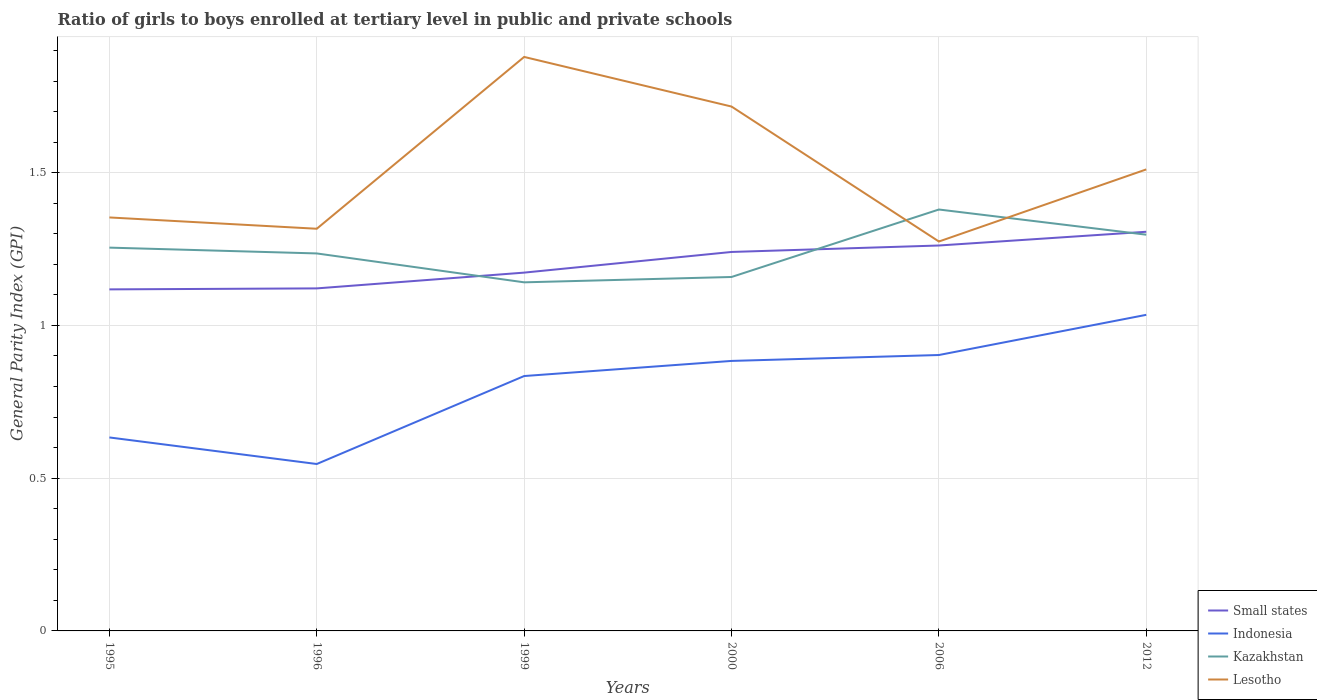How many different coloured lines are there?
Your response must be concise. 4. Does the line corresponding to Indonesia intersect with the line corresponding to Small states?
Keep it short and to the point. No. Across all years, what is the maximum general parity index in Indonesia?
Your answer should be compact. 0.55. In which year was the general parity index in Small states maximum?
Provide a short and direct response. 1995. What is the total general parity index in Lesotho in the graph?
Your answer should be compact. 0.37. What is the difference between the highest and the second highest general parity index in Indonesia?
Ensure brevity in your answer.  0.49. What is the difference between the highest and the lowest general parity index in Small states?
Ensure brevity in your answer.  3. Are the values on the major ticks of Y-axis written in scientific E-notation?
Make the answer very short. No. Does the graph contain grids?
Your response must be concise. Yes. Where does the legend appear in the graph?
Your answer should be very brief. Bottom right. How are the legend labels stacked?
Offer a terse response. Vertical. What is the title of the graph?
Give a very brief answer. Ratio of girls to boys enrolled at tertiary level in public and private schools. What is the label or title of the Y-axis?
Give a very brief answer. General Parity Index (GPI). What is the General Parity Index (GPI) of Small states in 1995?
Your answer should be compact. 1.12. What is the General Parity Index (GPI) in Indonesia in 1995?
Keep it short and to the point. 0.63. What is the General Parity Index (GPI) of Kazakhstan in 1995?
Make the answer very short. 1.25. What is the General Parity Index (GPI) of Lesotho in 1995?
Your answer should be very brief. 1.35. What is the General Parity Index (GPI) of Small states in 1996?
Your answer should be very brief. 1.12. What is the General Parity Index (GPI) in Indonesia in 1996?
Offer a very short reply. 0.55. What is the General Parity Index (GPI) in Kazakhstan in 1996?
Give a very brief answer. 1.24. What is the General Parity Index (GPI) in Lesotho in 1996?
Your answer should be compact. 1.32. What is the General Parity Index (GPI) in Small states in 1999?
Your answer should be very brief. 1.17. What is the General Parity Index (GPI) of Indonesia in 1999?
Your response must be concise. 0.83. What is the General Parity Index (GPI) in Kazakhstan in 1999?
Provide a succinct answer. 1.14. What is the General Parity Index (GPI) in Lesotho in 1999?
Give a very brief answer. 1.88. What is the General Parity Index (GPI) of Small states in 2000?
Your answer should be very brief. 1.24. What is the General Parity Index (GPI) of Indonesia in 2000?
Your response must be concise. 0.88. What is the General Parity Index (GPI) in Kazakhstan in 2000?
Your response must be concise. 1.16. What is the General Parity Index (GPI) of Lesotho in 2000?
Give a very brief answer. 1.72. What is the General Parity Index (GPI) of Small states in 2006?
Your response must be concise. 1.26. What is the General Parity Index (GPI) of Indonesia in 2006?
Offer a very short reply. 0.9. What is the General Parity Index (GPI) in Kazakhstan in 2006?
Provide a succinct answer. 1.38. What is the General Parity Index (GPI) in Lesotho in 2006?
Make the answer very short. 1.27. What is the General Parity Index (GPI) of Small states in 2012?
Your response must be concise. 1.31. What is the General Parity Index (GPI) of Indonesia in 2012?
Your answer should be compact. 1.03. What is the General Parity Index (GPI) in Kazakhstan in 2012?
Provide a succinct answer. 1.3. What is the General Parity Index (GPI) in Lesotho in 2012?
Keep it short and to the point. 1.51. Across all years, what is the maximum General Parity Index (GPI) in Small states?
Give a very brief answer. 1.31. Across all years, what is the maximum General Parity Index (GPI) in Indonesia?
Keep it short and to the point. 1.03. Across all years, what is the maximum General Parity Index (GPI) in Kazakhstan?
Your answer should be compact. 1.38. Across all years, what is the maximum General Parity Index (GPI) of Lesotho?
Your answer should be very brief. 1.88. Across all years, what is the minimum General Parity Index (GPI) of Small states?
Offer a terse response. 1.12. Across all years, what is the minimum General Parity Index (GPI) of Indonesia?
Your response must be concise. 0.55. Across all years, what is the minimum General Parity Index (GPI) in Kazakhstan?
Give a very brief answer. 1.14. Across all years, what is the minimum General Parity Index (GPI) of Lesotho?
Your response must be concise. 1.27. What is the total General Parity Index (GPI) of Small states in the graph?
Provide a short and direct response. 7.22. What is the total General Parity Index (GPI) of Indonesia in the graph?
Keep it short and to the point. 4.84. What is the total General Parity Index (GPI) of Kazakhstan in the graph?
Offer a very short reply. 7.47. What is the total General Parity Index (GPI) in Lesotho in the graph?
Offer a very short reply. 9.05. What is the difference between the General Parity Index (GPI) of Small states in 1995 and that in 1996?
Offer a very short reply. -0. What is the difference between the General Parity Index (GPI) in Indonesia in 1995 and that in 1996?
Provide a succinct answer. 0.09. What is the difference between the General Parity Index (GPI) of Kazakhstan in 1995 and that in 1996?
Ensure brevity in your answer.  0.02. What is the difference between the General Parity Index (GPI) in Lesotho in 1995 and that in 1996?
Offer a terse response. 0.04. What is the difference between the General Parity Index (GPI) in Small states in 1995 and that in 1999?
Your answer should be compact. -0.05. What is the difference between the General Parity Index (GPI) in Indonesia in 1995 and that in 1999?
Your answer should be very brief. -0.2. What is the difference between the General Parity Index (GPI) in Kazakhstan in 1995 and that in 1999?
Keep it short and to the point. 0.11. What is the difference between the General Parity Index (GPI) of Lesotho in 1995 and that in 1999?
Offer a very short reply. -0.53. What is the difference between the General Parity Index (GPI) of Small states in 1995 and that in 2000?
Provide a short and direct response. -0.12. What is the difference between the General Parity Index (GPI) of Indonesia in 1995 and that in 2000?
Keep it short and to the point. -0.25. What is the difference between the General Parity Index (GPI) in Kazakhstan in 1995 and that in 2000?
Offer a very short reply. 0.1. What is the difference between the General Parity Index (GPI) of Lesotho in 1995 and that in 2000?
Ensure brevity in your answer.  -0.36. What is the difference between the General Parity Index (GPI) of Small states in 1995 and that in 2006?
Make the answer very short. -0.14. What is the difference between the General Parity Index (GPI) in Indonesia in 1995 and that in 2006?
Give a very brief answer. -0.27. What is the difference between the General Parity Index (GPI) of Kazakhstan in 1995 and that in 2006?
Keep it short and to the point. -0.12. What is the difference between the General Parity Index (GPI) of Lesotho in 1995 and that in 2006?
Your answer should be compact. 0.08. What is the difference between the General Parity Index (GPI) in Small states in 1995 and that in 2012?
Keep it short and to the point. -0.19. What is the difference between the General Parity Index (GPI) of Indonesia in 1995 and that in 2012?
Offer a very short reply. -0.4. What is the difference between the General Parity Index (GPI) in Kazakhstan in 1995 and that in 2012?
Provide a short and direct response. -0.04. What is the difference between the General Parity Index (GPI) in Lesotho in 1995 and that in 2012?
Give a very brief answer. -0.16. What is the difference between the General Parity Index (GPI) of Small states in 1996 and that in 1999?
Provide a succinct answer. -0.05. What is the difference between the General Parity Index (GPI) of Indonesia in 1996 and that in 1999?
Keep it short and to the point. -0.29. What is the difference between the General Parity Index (GPI) of Kazakhstan in 1996 and that in 1999?
Make the answer very short. 0.09. What is the difference between the General Parity Index (GPI) in Lesotho in 1996 and that in 1999?
Make the answer very short. -0.56. What is the difference between the General Parity Index (GPI) in Small states in 1996 and that in 2000?
Ensure brevity in your answer.  -0.12. What is the difference between the General Parity Index (GPI) of Indonesia in 1996 and that in 2000?
Give a very brief answer. -0.34. What is the difference between the General Parity Index (GPI) in Kazakhstan in 1996 and that in 2000?
Make the answer very short. 0.08. What is the difference between the General Parity Index (GPI) in Small states in 1996 and that in 2006?
Provide a succinct answer. -0.14. What is the difference between the General Parity Index (GPI) of Indonesia in 1996 and that in 2006?
Ensure brevity in your answer.  -0.36. What is the difference between the General Parity Index (GPI) of Kazakhstan in 1996 and that in 2006?
Your answer should be compact. -0.14. What is the difference between the General Parity Index (GPI) in Lesotho in 1996 and that in 2006?
Offer a very short reply. 0.04. What is the difference between the General Parity Index (GPI) of Small states in 1996 and that in 2012?
Your response must be concise. -0.19. What is the difference between the General Parity Index (GPI) of Indonesia in 1996 and that in 2012?
Your answer should be very brief. -0.49. What is the difference between the General Parity Index (GPI) of Kazakhstan in 1996 and that in 2012?
Keep it short and to the point. -0.06. What is the difference between the General Parity Index (GPI) of Lesotho in 1996 and that in 2012?
Give a very brief answer. -0.19. What is the difference between the General Parity Index (GPI) of Small states in 1999 and that in 2000?
Your answer should be compact. -0.07. What is the difference between the General Parity Index (GPI) in Indonesia in 1999 and that in 2000?
Keep it short and to the point. -0.05. What is the difference between the General Parity Index (GPI) in Kazakhstan in 1999 and that in 2000?
Your response must be concise. -0.02. What is the difference between the General Parity Index (GPI) in Lesotho in 1999 and that in 2000?
Ensure brevity in your answer.  0.16. What is the difference between the General Parity Index (GPI) in Small states in 1999 and that in 2006?
Offer a very short reply. -0.09. What is the difference between the General Parity Index (GPI) of Indonesia in 1999 and that in 2006?
Give a very brief answer. -0.07. What is the difference between the General Parity Index (GPI) in Kazakhstan in 1999 and that in 2006?
Your answer should be very brief. -0.24. What is the difference between the General Parity Index (GPI) of Lesotho in 1999 and that in 2006?
Provide a succinct answer. 0.6. What is the difference between the General Parity Index (GPI) of Small states in 1999 and that in 2012?
Provide a short and direct response. -0.13. What is the difference between the General Parity Index (GPI) in Indonesia in 1999 and that in 2012?
Your response must be concise. -0.2. What is the difference between the General Parity Index (GPI) of Kazakhstan in 1999 and that in 2012?
Give a very brief answer. -0.16. What is the difference between the General Parity Index (GPI) in Lesotho in 1999 and that in 2012?
Offer a terse response. 0.37. What is the difference between the General Parity Index (GPI) of Small states in 2000 and that in 2006?
Give a very brief answer. -0.02. What is the difference between the General Parity Index (GPI) of Indonesia in 2000 and that in 2006?
Make the answer very short. -0.02. What is the difference between the General Parity Index (GPI) of Kazakhstan in 2000 and that in 2006?
Offer a very short reply. -0.22. What is the difference between the General Parity Index (GPI) in Lesotho in 2000 and that in 2006?
Keep it short and to the point. 0.44. What is the difference between the General Parity Index (GPI) in Small states in 2000 and that in 2012?
Provide a short and direct response. -0.07. What is the difference between the General Parity Index (GPI) in Indonesia in 2000 and that in 2012?
Keep it short and to the point. -0.15. What is the difference between the General Parity Index (GPI) in Kazakhstan in 2000 and that in 2012?
Give a very brief answer. -0.14. What is the difference between the General Parity Index (GPI) in Lesotho in 2000 and that in 2012?
Your response must be concise. 0.21. What is the difference between the General Parity Index (GPI) of Small states in 2006 and that in 2012?
Offer a terse response. -0.04. What is the difference between the General Parity Index (GPI) in Indonesia in 2006 and that in 2012?
Keep it short and to the point. -0.13. What is the difference between the General Parity Index (GPI) in Kazakhstan in 2006 and that in 2012?
Ensure brevity in your answer.  0.08. What is the difference between the General Parity Index (GPI) in Lesotho in 2006 and that in 2012?
Ensure brevity in your answer.  -0.24. What is the difference between the General Parity Index (GPI) in Small states in 1995 and the General Parity Index (GPI) in Indonesia in 1996?
Provide a succinct answer. 0.57. What is the difference between the General Parity Index (GPI) of Small states in 1995 and the General Parity Index (GPI) of Kazakhstan in 1996?
Keep it short and to the point. -0.12. What is the difference between the General Parity Index (GPI) of Small states in 1995 and the General Parity Index (GPI) of Lesotho in 1996?
Make the answer very short. -0.2. What is the difference between the General Parity Index (GPI) in Indonesia in 1995 and the General Parity Index (GPI) in Kazakhstan in 1996?
Provide a short and direct response. -0.6. What is the difference between the General Parity Index (GPI) of Indonesia in 1995 and the General Parity Index (GPI) of Lesotho in 1996?
Your answer should be compact. -0.68. What is the difference between the General Parity Index (GPI) in Kazakhstan in 1995 and the General Parity Index (GPI) in Lesotho in 1996?
Your response must be concise. -0.06. What is the difference between the General Parity Index (GPI) in Small states in 1995 and the General Parity Index (GPI) in Indonesia in 1999?
Your response must be concise. 0.28. What is the difference between the General Parity Index (GPI) of Small states in 1995 and the General Parity Index (GPI) of Kazakhstan in 1999?
Your answer should be very brief. -0.02. What is the difference between the General Parity Index (GPI) in Small states in 1995 and the General Parity Index (GPI) in Lesotho in 1999?
Provide a short and direct response. -0.76. What is the difference between the General Parity Index (GPI) of Indonesia in 1995 and the General Parity Index (GPI) of Kazakhstan in 1999?
Your response must be concise. -0.51. What is the difference between the General Parity Index (GPI) of Indonesia in 1995 and the General Parity Index (GPI) of Lesotho in 1999?
Offer a very short reply. -1.25. What is the difference between the General Parity Index (GPI) of Kazakhstan in 1995 and the General Parity Index (GPI) of Lesotho in 1999?
Your answer should be very brief. -0.62. What is the difference between the General Parity Index (GPI) in Small states in 1995 and the General Parity Index (GPI) in Indonesia in 2000?
Give a very brief answer. 0.23. What is the difference between the General Parity Index (GPI) of Small states in 1995 and the General Parity Index (GPI) of Kazakhstan in 2000?
Your answer should be very brief. -0.04. What is the difference between the General Parity Index (GPI) of Small states in 1995 and the General Parity Index (GPI) of Lesotho in 2000?
Ensure brevity in your answer.  -0.6. What is the difference between the General Parity Index (GPI) of Indonesia in 1995 and the General Parity Index (GPI) of Kazakhstan in 2000?
Ensure brevity in your answer.  -0.53. What is the difference between the General Parity Index (GPI) in Indonesia in 1995 and the General Parity Index (GPI) in Lesotho in 2000?
Provide a succinct answer. -1.08. What is the difference between the General Parity Index (GPI) in Kazakhstan in 1995 and the General Parity Index (GPI) in Lesotho in 2000?
Keep it short and to the point. -0.46. What is the difference between the General Parity Index (GPI) in Small states in 1995 and the General Parity Index (GPI) in Indonesia in 2006?
Provide a short and direct response. 0.21. What is the difference between the General Parity Index (GPI) in Small states in 1995 and the General Parity Index (GPI) in Kazakhstan in 2006?
Provide a short and direct response. -0.26. What is the difference between the General Parity Index (GPI) in Small states in 1995 and the General Parity Index (GPI) in Lesotho in 2006?
Offer a very short reply. -0.16. What is the difference between the General Parity Index (GPI) in Indonesia in 1995 and the General Parity Index (GPI) in Kazakhstan in 2006?
Provide a succinct answer. -0.75. What is the difference between the General Parity Index (GPI) in Indonesia in 1995 and the General Parity Index (GPI) in Lesotho in 2006?
Offer a very short reply. -0.64. What is the difference between the General Parity Index (GPI) in Kazakhstan in 1995 and the General Parity Index (GPI) in Lesotho in 2006?
Ensure brevity in your answer.  -0.02. What is the difference between the General Parity Index (GPI) of Small states in 1995 and the General Parity Index (GPI) of Indonesia in 2012?
Provide a short and direct response. 0.08. What is the difference between the General Parity Index (GPI) in Small states in 1995 and the General Parity Index (GPI) in Kazakhstan in 2012?
Make the answer very short. -0.18. What is the difference between the General Parity Index (GPI) of Small states in 1995 and the General Parity Index (GPI) of Lesotho in 2012?
Offer a terse response. -0.39. What is the difference between the General Parity Index (GPI) in Indonesia in 1995 and the General Parity Index (GPI) in Kazakhstan in 2012?
Provide a short and direct response. -0.66. What is the difference between the General Parity Index (GPI) of Indonesia in 1995 and the General Parity Index (GPI) of Lesotho in 2012?
Make the answer very short. -0.88. What is the difference between the General Parity Index (GPI) in Kazakhstan in 1995 and the General Parity Index (GPI) in Lesotho in 2012?
Your answer should be very brief. -0.26. What is the difference between the General Parity Index (GPI) in Small states in 1996 and the General Parity Index (GPI) in Indonesia in 1999?
Give a very brief answer. 0.29. What is the difference between the General Parity Index (GPI) in Small states in 1996 and the General Parity Index (GPI) in Kazakhstan in 1999?
Ensure brevity in your answer.  -0.02. What is the difference between the General Parity Index (GPI) in Small states in 1996 and the General Parity Index (GPI) in Lesotho in 1999?
Your answer should be compact. -0.76. What is the difference between the General Parity Index (GPI) of Indonesia in 1996 and the General Parity Index (GPI) of Kazakhstan in 1999?
Offer a terse response. -0.59. What is the difference between the General Parity Index (GPI) in Indonesia in 1996 and the General Parity Index (GPI) in Lesotho in 1999?
Ensure brevity in your answer.  -1.33. What is the difference between the General Parity Index (GPI) of Kazakhstan in 1996 and the General Parity Index (GPI) of Lesotho in 1999?
Your answer should be compact. -0.64. What is the difference between the General Parity Index (GPI) of Small states in 1996 and the General Parity Index (GPI) of Indonesia in 2000?
Provide a short and direct response. 0.24. What is the difference between the General Parity Index (GPI) in Small states in 1996 and the General Parity Index (GPI) in Kazakhstan in 2000?
Your response must be concise. -0.04. What is the difference between the General Parity Index (GPI) in Small states in 1996 and the General Parity Index (GPI) in Lesotho in 2000?
Your answer should be very brief. -0.6. What is the difference between the General Parity Index (GPI) in Indonesia in 1996 and the General Parity Index (GPI) in Kazakhstan in 2000?
Provide a short and direct response. -0.61. What is the difference between the General Parity Index (GPI) in Indonesia in 1996 and the General Parity Index (GPI) in Lesotho in 2000?
Your response must be concise. -1.17. What is the difference between the General Parity Index (GPI) of Kazakhstan in 1996 and the General Parity Index (GPI) of Lesotho in 2000?
Your answer should be very brief. -0.48. What is the difference between the General Parity Index (GPI) in Small states in 1996 and the General Parity Index (GPI) in Indonesia in 2006?
Make the answer very short. 0.22. What is the difference between the General Parity Index (GPI) in Small states in 1996 and the General Parity Index (GPI) in Kazakhstan in 2006?
Provide a succinct answer. -0.26. What is the difference between the General Parity Index (GPI) of Small states in 1996 and the General Parity Index (GPI) of Lesotho in 2006?
Your answer should be very brief. -0.15. What is the difference between the General Parity Index (GPI) of Indonesia in 1996 and the General Parity Index (GPI) of Kazakhstan in 2006?
Your answer should be compact. -0.83. What is the difference between the General Parity Index (GPI) in Indonesia in 1996 and the General Parity Index (GPI) in Lesotho in 2006?
Keep it short and to the point. -0.73. What is the difference between the General Parity Index (GPI) of Kazakhstan in 1996 and the General Parity Index (GPI) of Lesotho in 2006?
Give a very brief answer. -0.04. What is the difference between the General Parity Index (GPI) of Small states in 1996 and the General Parity Index (GPI) of Indonesia in 2012?
Make the answer very short. 0.09. What is the difference between the General Parity Index (GPI) of Small states in 1996 and the General Parity Index (GPI) of Kazakhstan in 2012?
Give a very brief answer. -0.18. What is the difference between the General Parity Index (GPI) in Small states in 1996 and the General Parity Index (GPI) in Lesotho in 2012?
Give a very brief answer. -0.39. What is the difference between the General Parity Index (GPI) of Indonesia in 1996 and the General Parity Index (GPI) of Kazakhstan in 2012?
Offer a terse response. -0.75. What is the difference between the General Parity Index (GPI) in Indonesia in 1996 and the General Parity Index (GPI) in Lesotho in 2012?
Provide a short and direct response. -0.96. What is the difference between the General Parity Index (GPI) in Kazakhstan in 1996 and the General Parity Index (GPI) in Lesotho in 2012?
Make the answer very short. -0.28. What is the difference between the General Parity Index (GPI) in Small states in 1999 and the General Parity Index (GPI) in Indonesia in 2000?
Provide a short and direct response. 0.29. What is the difference between the General Parity Index (GPI) of Small states in 1999 and the General Parity Index (GPI) of Kazakhstan in 2000?
Ensure brevity in your answer.  0.01. What is the difference between the General Parity Index (GPI) of Small states in 1999 and the General Parity Index (GPI) of Lesotho in 2000?
Ensure brevity in your answer.  -0.54. What is the difference between the General Parity Index (GPI) of Indonesia in 1999 and the General Parity Index (GPI) of Kazakhstan in 2000?
Give a very brief answer. -0.32. What is the difference between the General Parity Index (GPI) of Indonesia in 1999 and the General Parity Index (GPI) of Lesotho in 2000?
Offer a very short reply. -0.88. What is the difference between the General Parity Index (GPI) of Kazakhstan in 1999 and the General Parity Index (GPI) of Lesotho in 2000?
Your answer should be compact. -0.58. What is the difference between the General Parity Index (GPI) of Small states in 1999 and the General Parity Index (GPI) of Indonesia in 2006?
Make the answer very short. 0.27. What is the difference between the General Parity Index (GPI) of Small states in 1999 and the General Parity Index (GPI) of Kazakhstan in 2006?
Offer a very short reply. -0.21. What is the difference between the General Parity Index (GPI) of Small states in 1999 and the General Parity Index (GPI) of Lesotho in 2006?
Provide a short and direct response. -0.1. What is the difference between the General Parity Index (GPI) in Indonesia in 1999 and the General Parity Index (GPI) in Kazakhstan in 2006?
Your answer should be very brief. -0.55. What is the difference between the General Parity Index (GPI) of Indonesia in 1999 and the General Parity Index (GPI) of Lesotho in 2006?
Your answer should be very brief. -0.44. What is the difference between the General Parity Index (GPI) in Kazakhstan in 1999 and the General Parity Index (GPI) in Lesotho in 2006?
Make the answer very short. -0.13. What is the difference between the General Parity Index (GPI) of Small states in 1999 and the General Parity Index (GPI) of Indonesia in 2012?
Your answer should be very brief. 0.14. What is the difference between the General Parity Index (GPI) of Small states in 1999 and the General Parity Index (GPI) of Kazakhstan in 2012?
Keep it short and to the point. -0.12. What is the difference between the General Parity Index (GPI) in Small states in 1999 and the General Parity Index (GPI) in Lesotho in 2012?
Your answer should be very brief. -0.34. What is the difference between the General Parity Index (GPI) in Indonesia in 1999 and the General Parity Index (GPI) in Kazakhstan in 2012?
Give a very brief answer. -0.46. What is the difference between the General Parity Index (GPI) in Indonesia in 1999 and the General Parity Index (GPI) in Lesotho in 2012?
Keep it short and to the point. -0.68. What is the difference between the General Parity Index (GPI) of Kazakhstan in 1999 and the General Parity Index (GPI) of Lesotho in 2012?
Offer a terse response. -0.37. What is the difference between the General Parity Index (GPI) of Small states in 2000 and the General Parity Index (GPI) of Indonesia in 2006?
Ensure brevity in your answer.  0.34. What is the difference between the General Parity Index (GPI) of Small states in 2000 and the General Parity Index (GPI) of Kazakhstan in 2006?
Offer a terse response. -0.14. What is the difference between the General Parity Index (GPI) in Small states in 2000 and the General Parity Index (GPI) in Lesotho in 2006?
Offer a very short reply. -0.03. What is the difference between the General Parity Index (GPI) in Indonesia in 2000 and the General Parity Index (GPI) in Kazakhstan in 2006?
Offer a terse response. -0.5. What is the difference between the General Parity Index (GPI) in Indonesia in 2000 and the General Parity Index (GPI) in Lesotho in 2006?
Offer a terse response. -0.39. What is the difference between the General Parity Index (GPI) in Kazakhstan in 2000 and the General Parity Index (GPI) in Lesotho in 2006?
Make the answer very short. -0.12. What is the difference between the General Parity Index (GPI) in Small states in 2000 and the General Parity Index (GPI) in Indonesia in 2012?
Give a very brief answer. 0.21. What is the difference between the General Parity Index (GPI) in Small states in 2000 and the General Parity Index (GPI) in Kazakhstan in 2012?
Offer a terse response. -0.06. What is the difference between the General Parity Index (GPI) in Small states in 2000 and the General Parity Index (GPI) in Lesotho in 2012?
Your answer should be compact. -0.27. What is the difference between the General Parity Index (GPI) of Indonesia in 2000 and the General Parity Index (GPI) of Kazakhstan in 2012?
Your response must be concise. -0.41. What is the difference between the General Parity Index (GPI) in Indonesia in 2000 and the General Parity Index (GPI) in Lesotho in 2012?
Provide a succinct answer. -0.63. What is the difference between the General Parity Index (GPI) of Kazakhstan in 2000 and the General Parity Index (GPI) of Lesotho in 2012?
Your answer should be compact. -0.35. What is the difference between the General Parity Index (GPI) of Small states in 2006 and the General Parity Index (GPI) of Indonesia in 2012?
Ensure brevity in your answer.  0.23. What is the difference between the General Parity Index (GPI) of Small states in 2006 and the General Parity Index (GPI) of Kazakhstan in 2012?
Your response must be concise. -0.04. What is the difference between the General Parity Index (GPI) in Small states in 2006 and the General Parity Index (GPI) in Lesotho in 2012?
Make the answer very short. -0.25. What is the difference between the General Parity Index (GPI) of Indonesia in 2006 and the General Parity Index (GPI) of Kazakhstan in 2012?
Offer a terse response. -0.39. What is the difference between the General Parity Index (GPI) of Indonesia in 2006 and the General Parity Index (GPI) of Lesotho in 2012?
Offer a terse response. -0.61. What is the difference between the General Parity Index (GPI) in Kazakhstan in 2006 and the General Parity Index (GPI) in Lesotho in 2012?
Provide a succinct answer. -0.13. What is the average General Parity Index (GPI) in Small states per year?
Provide a short and direct response. 1.2. What is the average General Parity Index (GPI) in Indonesia per year?
Offer a terse response. 0.81. What is the average General Parity Index (GPI) in Kazakhstan per year?
Your answer should be very brief. 1.24. What is the average General Parity Index (GPI) in Lesotho per year?
Offer a very short reply. 1.51. In the year 1995, what is the difference between the General Parity Index (GPI) of Small states and General Parity Index (GPI) of Indonesia?
Offer a very short reply. 0.48. In the year 1995, what is the difference between the General Parity Index (GPI) of Small states and General Parity Index (GPI) of Kazakhstan?
Keep it short and to the point. -0.14. In the year 1995, what is the difference between the General Parity Index (GPI) of Small states and General Parity Index (GPI) of Lesotho?
Provide a succinct answer. -0.24. In the year 1995, what is the difference between the General Parity Index (GPI) of Indonesia and General Parity Index (GPI) of Kazakhstan?
Your answer should be very brief. -0.62. In the year 1995, what is the difference between the General Parity Index (GPI) in Indonesia and General Parity Index (GPI) in Lesotho?
Ensure brevity in your answer.  -0.72. In the year 1995, what is the difference between the General Parity Index (GPI) in Kazakhstan and General Parity Index (GPI) in Lesotho?
Your response must be concise. -0.1. In the year 1996, what is the difference between the General Parity Index (GPI) of Small states and General Parity Index (GPI) of Indonesia?
Make the answer very short. 0.57. In the year 1996, what is the difference between the General Parity Index (GPI) of Small states and General Parity Index (GPI) of Kazakhstan?
Your answer should be very brief. -0.11. In the year 1996, what is the difference between the General Parity Index (GPI) in Small states and General Parity Index (GPI) in Lesotho?
Offer a very short reply. -0.2. In the year 1996, what is the difference between the General Parity Index (GPI) of Indonesia and General Parity Index (GPI) of Kazakhstan?
Your answer should be compact. -0.69. In the year 1996, what is the difference between the General Parity Index (GPI) in Indonesia and General Parity Index (GPI) in Lesotho?
Ensure brevity in your answer.  -0.77. In the year 1996, what is the difference between the General Parity Index (GPI) in Kazakhstan and General Parity Index (GPI) in Lesotho?
Offer a terse response. -0.08. In the year 1999, what is the difference between the General Parity Index (GPI) in Small states and General Parity Index (GPI) in Indonesia?
Keep it short and to the point. 0.34. In the year 1999, what is the difference between the General Parity Index (GPI) in Small states and General Parity Index (GPI) in Kazakhstan?
Provide a succinct answer. 0.03. In the year 1999, what is the difference between the General Parity Index (GPI) of Small states and General Parity Index (GPI) of Lesotho?
Offer a terse response. -0.71. In the year 1999, what is the difference between the General Parity Index (GPI) of Indonesia and General Parity Index (GPI) of Kazakhstan?
Your response must be concise. -0.31. In the year 1999, what is the difference between the General Parity Index (GPI) in Indonesia and General Parity Index (GPI) in Lesotho?
Keep it short and to the point. -1.04. In the year 1999, what is the difference between the General Parity Index (GPI) in Kazakhstan and General Parity Index (GPI) in Lesotho?
Offer a very short reply. -0.74. In the year 2000, what is the difference between the General Parity Index (GPI) in Small states and General Parity Index (GPI) in Indonesia?
Your response must be concise. 0.36. In the year 2000, what is the difference between the General Parity Index (GPI) of Small states and General Parity Index (GPI) of Kazakhstan?
Your answer should be very brief. 0.08. In the year 2000, what is the difference between the General Parity Index (GPI) in Small states and General Parity Index (GPI) in Lesotho?
Offer a terse response. -0.48. In the year 2000, what is the difference between the General Parity Index (GPI) in Indonesia and General Parity Index (GPI) in Kazakhstan?
Provide a succinct answer. -0.27. In the year 2000, what is the difference between the General Parity Index (GPI) in Indonesia and General Parity Index (GPI) in Lesotho?
Ensure brevity in your answer.  -0.83. In the year 2000, what is the difference between the General Parity Index (GPI) in Kazakhstan and General Parity Index (GPI) in Lesotho?
Your answer should be very brief. -0.56. In the year 2006, what is the difference between the General Parity Index (GPI) of Small states and General Parity Index (GPI) of Indonesia?
Keep it short and to the point. 0.36. In the year 2006, what is the difference between the General Parity Index (GPI) of Small states and General Parity Index (GPI) of Kazakhstan?
Your answer should be compact. -0.12. In the year 2006, what is the difference between the General Parity Index (GPI) in Small states and General Parity Index (GPI) in Lesotho?
Give a very brief answer. -0.01. In the year 2006, what is the difference between the General Parity Index (GPI) of Indonesia and General Parity Index (GPI) of Kazakhstan?
Offer a very short reply. -0.48. In the year 2006, what is the difference between the General Parity Index (GPI) in Indonesia and General Parity Index (GPI) in Lesotho?
Your response must be concise. -0.37. In the year 2006, what is the difference between the General Parity Index (GPI) of Kazakhstan and General Parity Index (GPI) of Lesotho?
Provide a succinct answer. 0.1. In the year 2012, what is the difference between the General Parity Index (GPI) of Small states and General Parity Index (GPI) of Indonesia?
Give a very brief answer. 0.27. In the year 2012, what is the difference between the General Parity Index (GPI) of Small states and General Parity Index (GPI) of Kazakhstan?
Offer a very short reply. 0.01. In the year 2012, what is the difference between the General Parity Index (GPI) in Small states and General Parity Index (GPI) in Lesotho?
Make the answer very short. -0.2. In the year 2012, what is the difference between the General Parity Index (GPI) of Indonesia and General Parity Index (GPI) of Kazakhstan?
Make the answer very short. -0.26. In the year 2012, what is the difference between the General Parity Index (GPI) of Indonesia and General Parity Index (GPI) of Lesotho?
Provide a short and direct response. -0.48. In the year 2012, what is the difference between the General Parity Index (GPI) in Kazakhstan and General Parity Index (GPI) in Lesotho?
Offer a very short reply. -0.21. What is the ratio of the General Parity Index (GPI) of Indonesia in 1995 to that in 1996?
Provide a succinct answer. 1.16. What is the ratio of the General Parity Index (GPI) of Kazakhstan in 1995 to that in 1996?
Your response must be concise. 1.02. What is the ratio of the General Parity Index (GPI) of Lesotho in 1995 to that in 1996?
Your answer should be compact. 1.03. What is the ratio of the General Parity Index (GPI) of Small states in 1995 to that in 1999?
Provide a succinct answer. 0.95. What is the ratio of the General Parity Index (GPI) in Indonesia in 1995 to that in 1999?
Your answer should be compact. 0.76. What is the ratio of the General Parity Index (GPI) in Kazakhstan in 1995 to that in 1999?
Give a very brief answer. 1.1. What is the ratio of the General Parity Index (GPI) of Lesotho in 1995 to that in 1999?
Give a very brief answer. 0.72. What is the ratio of the General Parity Index (GPI) of Small states in 1995 to that in 2000?
Make the answer very short. 0.9. What is the ratio of the General Parity Index (GPI) of Indonesia in 1995 to that in 2000?
Make the answer very short. 0.72. What is the ratio of the General Parity Index (GPI) in Kazakhstan in 1995 to that in 2000?
Your response must be concise. 1.08. What is the ratio of the General Parity Index (GPI) in Lesotho in 1995 to that in 2000?
Provide a succinct answer. 0.79. What is the ratio of the General Parity Index (GPI) of Small states in 1995 to that in 2006?
Ensure brevity in your answer.  0.89. What is the ratio of the General Parity Index (GPI) of Indonesia in 1995 to that in 2006?
Your answer should be very brief. 0.7. What is the ratio of the General Parity Index (GPI) in Kazakhstan in 1995 to that in 2006?
Keep it short and to the point. 0.91. What is the ratio of the General Parity Index (GPI) of Lesotho in 1995 to that in 2006?
Give a very brief answer. 1.06. What is the ratio of the General Parity Index (GPI) in Small states in 1995 to that in 2012?
Your answer should be compact. 0.86. What is the ratio of the General Parity Index (GPI) in Indonesia in 1995 to that in 2012?
Provide a short and direct response. 0.61. What is the ratio of the General Parity Index (GPI) in Kazakhstan in 1995 to that in 2012?
Your answer should be very brief. 0.97. What is the ratio of the General Parity Index (GPI) in Lesotho in 1995 to that in 2012?
Give a very brief answer. 0.9. What is the ratio of the General Parity Index (GPI) of Small states in 1996 to that in 1999?
Your response must be concise. 0.96. What is the ratio of the General Parity Index (GPI) in Indonesia in 1996 to that in 1999?
Your response must be concise. 0.65. What is the ratio of the General Parity Index (GPI) in Kazakhstan in 1996 to that in 1999?
Provide a succinct answer. 1.08. What is the ratio of the General Parity Index (GPI) of Lesotho in 1996 to that in 1999?
Ensure brevity in your answer.  0.7. What is the ratio of the General Parity Index (GPI) of Small states in 1996 to that in 2000?
Your response must be concise. 0.9. What is the ratio of the General Parity Index (GPI) of Indonesia in 1996 to that in 2000?
Keep it short and to the point. 0.62. What is the ratio of the General Parity Index (GPI) in Kazakhstan in 1996 to that in 2000?
Make the answer very short. 1.07. What is the ratio of the General Parity Index (GPI) in Lesotho in 1996 to that in 2000?
Make the answer very short. 0.77. What is the ratio of the General Parity Index (GPI) in Small states in 1996 to that in 2006?
Provide a succinct answer. 0.89. What is the ratio of the General Parity Index (GPI) in Indonesia in 1996 to that in 2006?
Offer a terse response. 0.6. What is the ratio of the General Parity Index (GPI) in Kazakhstan in 1996 to that in 2006?
Your response must be concise. 0.9. What is the ratio of the General Parity Index (GPI) in Lesotho in 1996 to that in 2006?
Provide a succinct answer. 1.03. What is the ratio of the General Parity Index (GPI) of Small states in 1996 to that in 2012?
Make the answer very short. 0.86. What is the ratio of the General Parity Index (GPI) of Indonesia in 1996 to that in 2012?
Your response must be concise. 0.53. What is the ratio of the General Parity Index (GPI) in Kazakhstan in 1996 to that in 2012?
Give a very brief answer. 0.95. What is the ratio of the General Parity Index (GPI) in Lesotho in 1996 to that in 2012?
Your answer should be very brief. 0.87. What is the ratio of the General Parity Index (GPI) in Small states in 1999 to that in 2000?
Your answer should be very brief. 0.95. What is the ratio of the General Parity Index (GPI) in Indonesia in 1999 to that in 2000?
Keep it short and to the point. 0.94. What is the ratio of the General Parity Index (GPI) in Kazakhstan in 1999 to that in 2000?
Your answer should be compact. 0.98. What is the ratio of the General Parity Index (GPI) in Lesotho in 1999 to that in 2000?
Keep it short and to the point. 1.09. What is the ratio of the General Parity Index (GPI) of Small states in 1999 to that in 2006?
Your response must be concise. 0.93. What is the ratio of the General Parity Index (GPI) of Indonesia in 1999 to that in 2006?
Your answer should be compact. 0.92. What is the ratio of the General Parity Index (GPI) of Kazakhstan in 1999 to that in 2006?
Offer a very short reply. 0.83. What is the ratio of the General Parity Index (GPI) of Lesotho in 1999 to that in 2006?
Offer a terse response. 1.47. What is the ratio of the General Parity Index (GPI) of Small states in 1999 to that in 2012?
Your response must be concise. 0.9. What is the ratio of the General Parity Index (GPI) of Indonesia in 1999 to that in 2012?
Your response must be concise. 0.81. What is the ratio of the General Parity Index (GPI) in Kazakhstan in 1999 to that in 2012?
Keep it short and to the point. 0.88. What is the ratio of the General Parity Index (GPI) in Lesotho in 1999 to that in 2012?
Your response must be concise. 1.24. What is the ratio of the General Parity Index (GPI) in Small states in 2000 to that in 2006?
Your response must be concise. 0.98. What is the ratio of the General Parity Index (GPI) in Indonesia in 2000 to that in 2006?
Keep it short and to the point. 0.98. What is the ratio of the General Parity Index (GPI) in Kazakhstan in 2000 to that in 2006?
Your response must be concise. 0.84. What is the ratio of the General Parity Index (GPI) of Lesotho in 2000 to that in 2006?
Provide a short and direct response. 1.35. What is the ratio of the General Parity Index (GPI) in Small states in 2000 to that in 2012?
Offer a terse response. 0.95. What is the ratio of the General Parity Index (GPI) in Indonesia in 2000 to that in 2012?
Your answer should be compact. 0.85. What is the ratio of the General Parity Index (GPI) in Kazakhstan in 2000 to that in 2012?
Provide a short and direct response. 0.89. What is the ratio of the General Parity Index (GPI) of Lesotho in 2000 to that in 2012?
Ensure brevity in your answer.  1.14. What is the ratio of the General Parity Index (GPI) in Small states in 2006 to that in 2012?
Offer a terse response. 0.97. What is the ratio of the General Parity Index (GPI) of Indonesia in 2006 to that in 2012?
Your answer should be compact. 0.87. What is the ratio of the General Parity Index (GPI) of Kazakhstan in 2006 to that in 2012?
Provide a short and direct response. 1.06. What is the ratio of the General Parity Index (GPI) in Lesotho in 2006 to that in 2012?
Provide a succinct answer. 0.84. What is the difference between the highest and the second highest General Parity Index (GPI) in Small states?
Provide a short and direct response. 0.04. What is the difference between the highest and the second highest General Parity Index (GPI) in Indonesia?
Provide a short and direct response. 0.13. What is the difference between the highest and the second highest General Parity Index (GPI) of Kazakhstan?
Ensure brevity in your answer.  0.08. What is the difference between the highest and the second highest General Parity Index (GPI) in Lesotho?
Your answer should be very brief. 0.16. What is the difference between the highest and the lowest General Parity Index (GPI) of Small states?
Provide a short and direct response. 0.19. What is the difference between the highest and the lowest General Parity Index (GPI) in Indonesia?
Provide a succinct answer. 0.49. What is the difference between the highest and the lowest General Parity Index (GPI) in Kazakhstan?
Make the answer very short. 0.24. What is the difference between the highest and the lowest General Parity Index (GPI) of Lesotho?
Make the answer very short. 0.6. 